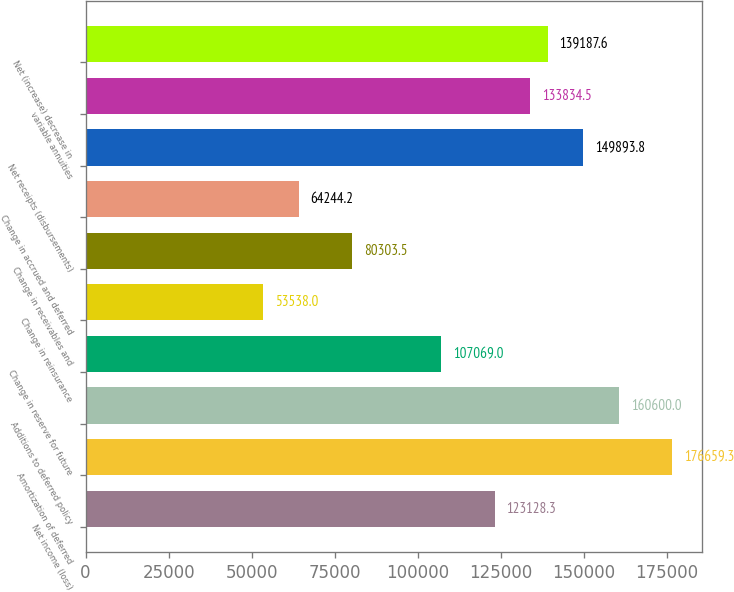Convert chart to OTSL. <chart><loc_0><loc_0><loc_500><loc_500><bar_chart><fcel>Net income (loss)<fcel>Amortization of deferred<fcel>Additions to deferred policy<fcel>Change in reserve for future<fcel>Change in reinsurance<fcel>Change in receivables and<fcel>Change in accrued and deferred<fcel>Net receipts (disbursements)<fcel>variable annuities<fcel>Net (increase) decrease in<nl><fcel>123128<fcel>176659<fcel>160600<fcel>107069<fcel>53538<fcel>80303.5<fcel>64244.2<fcel>149894<fcel>133834<fcel>139188<nl></chart> 